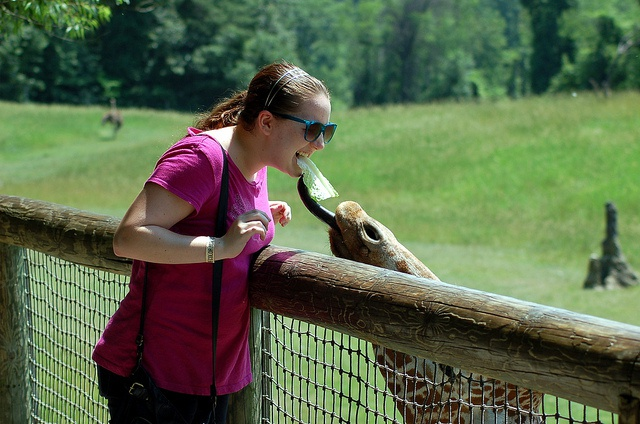Describe the objects in this image and their specific colors. I can see people in darkgreen, black, maroon, and gray tones, giraffe in darkgreen, black, gray, and beige tones, and handbag in darkgreen, black, maroon, and gray tones in this image. 